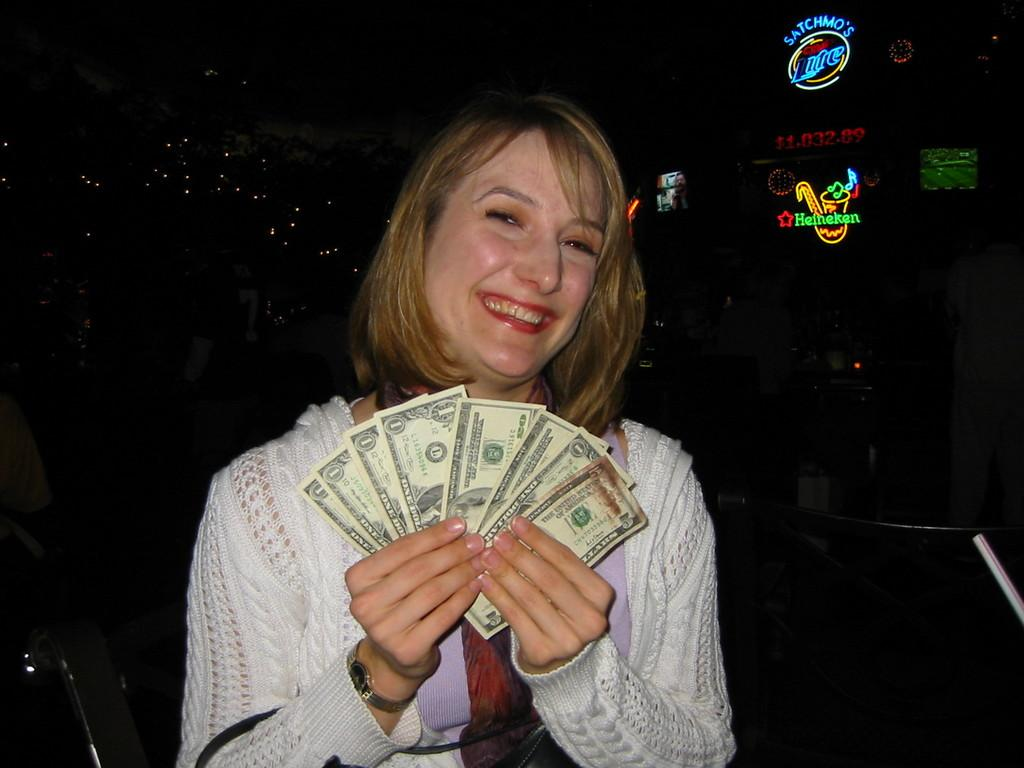Who is the main subject in the image? There is a lady in the center of the image. What is the lady holding in her hands? The lady is holding currency notes in her hands. What can be seen in the background of the image? There are posters and lights in the background of the image. What type of hair is the lady wearing in the image? There is no information about the lady's hair in the provided facts, so we cannot determine the type of hair she is wearing. How many posters are visible in the background of the image? The provided facts do not specify the number of posters in the background, so we cannot determine the exact number. 